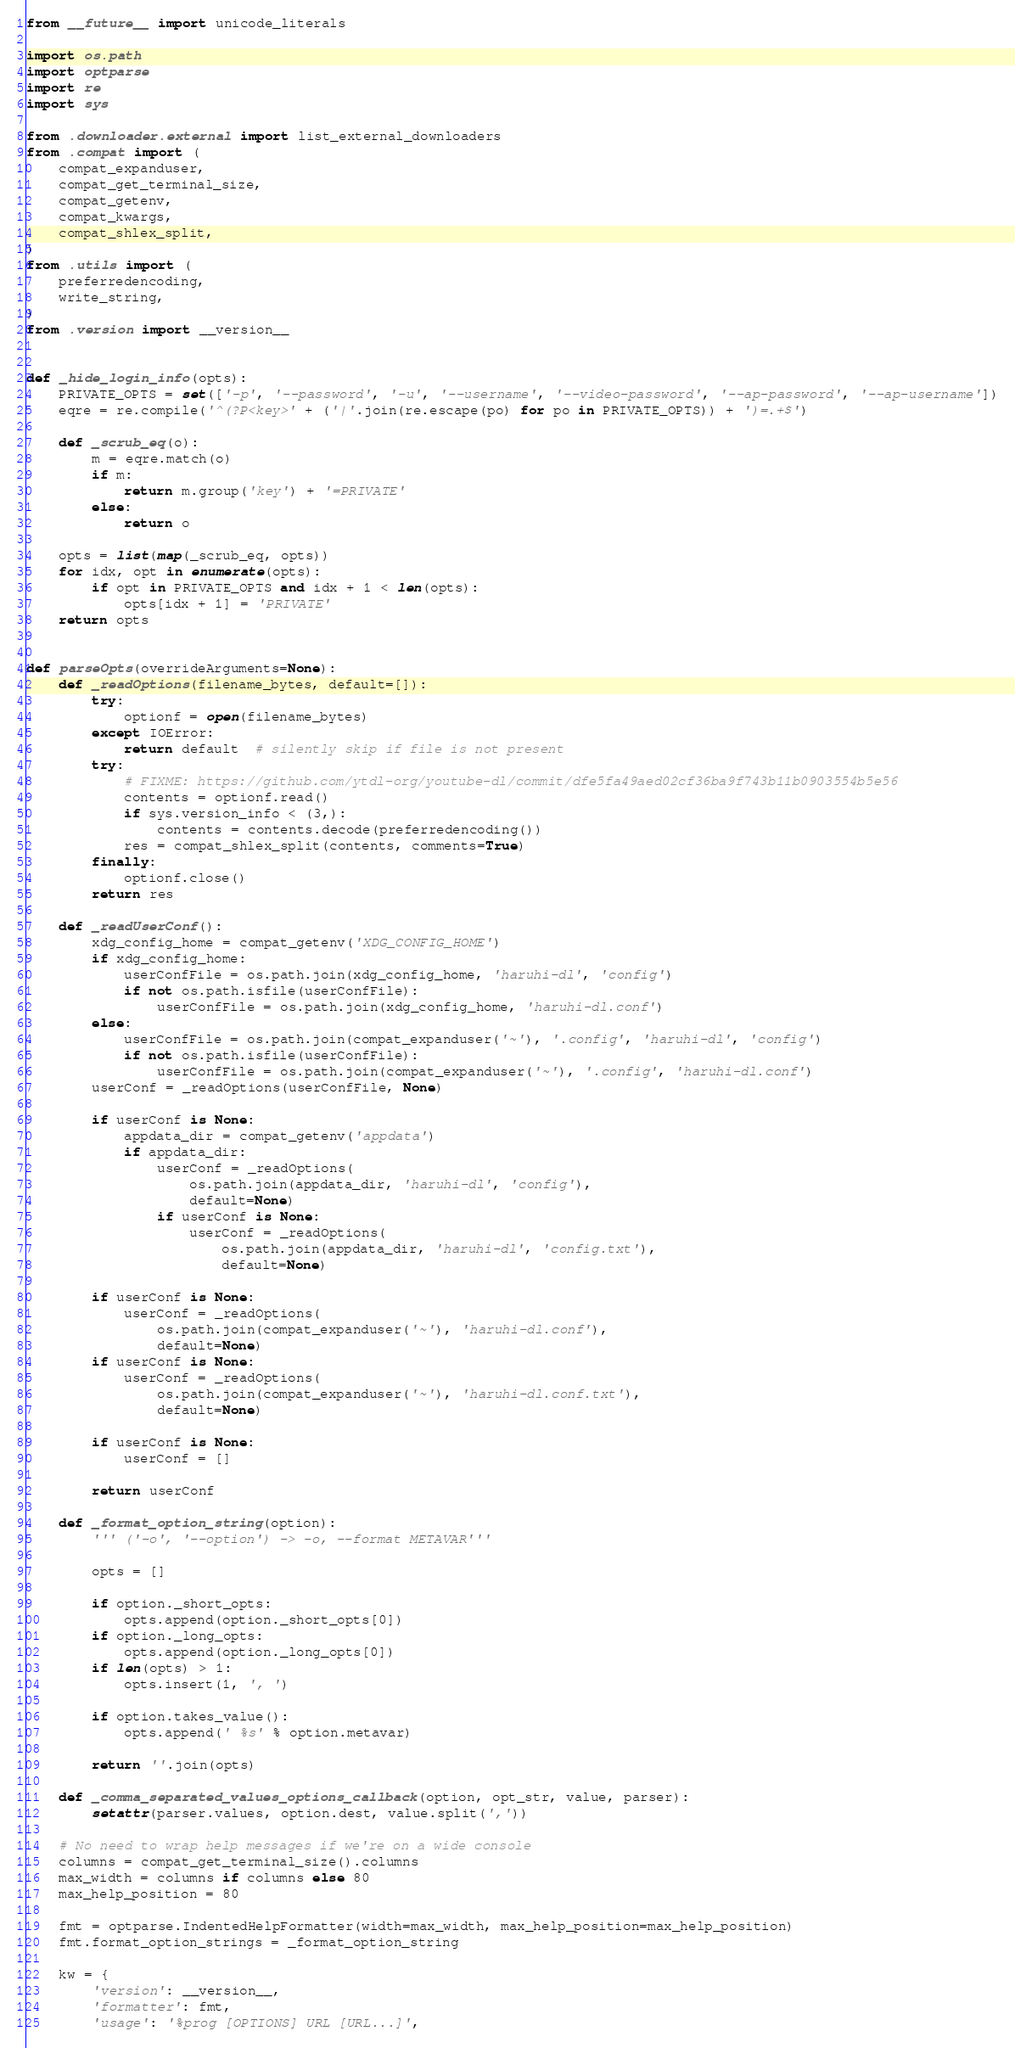<code> <loc_0><loc_0><loc_500><loc_500><_Python_>from __future__ import unicode_literals

import os.path
import optparse
import re
import sys

from .downloader.external import list_external_downloaders
from .compat import (
    compat_expanduser,
    compat_get_terminal_size,
    compat_getenv,
    compat_kwargs,
    compat_shlex_split,
)
from .utils import (
    preferredencoding,
    write_string,
)
from .version import __version__


def _hide_login_info(opts):
    PRIVATE_OPTS = set(['-p', '--password', '-u', '--username', '--video-password', '--ap-password', '--ap-username'])
    eqre = re.compile('^(?P<key>' + ('|'.join(re.escape(po) for po in PRIVATE_OPTS)) + ')=.+$')

    def _scrub_eq(o):
        m = eqre.match(o)
        if m:
            return m.group('key') + '=PRIVATE'
        else:
            return o

    opts = list(map(_scrub_eq, opts))
    for idx, opt in enumerate(opts):
        if opt in PRIVATE_OPTS and idx + 1 < len(opts):
            opts[idx + 1] = 'PRIVATE'
    return opts


def parseOpts(overrideArguments=None):
    def _readOptions(filename_bytes, default=[]):
        try:
            optionf = open(filename_bytes)
        except IOError:
            return default  # silently skip if file is not present
        try:
            # FIXME: https://github.com/ytdl-org/youtube-dl/commit/dfe5fa49aed02cf36ba9f743b11b0903554b5e56
            contents = optionf.read()
            if sys.version_info < (3,):
                contents = contents.decode(preferredencoding())
            res = compat_shlex_split(contents, comments=True)
        finally:
            optionf.close()
        return res

    def _readUserConf():
        xdg_config_home = compat_getenv('XDG_CONFIG_HOME')
        if xdg_config_home:
            userConfFile = os.path.join(xdg_config_home, 'haruhi-dl', 'config')
            if not os.path.isfile(userConfFile):
                userConfFile = os.path.join(xdg_config_home, 'haruhi-dl.conf')
        else:
            userConfFile = os.path.join(compat_expanduser('~'), '.config', 'haruhi-dl', 'config')
            if not os.path.isfile(userConfFile):
                userConfFile = os.path.join(compat_expanduser('~'), '.config', 'haruhi-dl.conf')
        userConf = _readOptions(userConfFile, None)

        if userConf is None:
            appdata_dir = compat_getenv('appdata')
            if appdata_dir:
                userConf = _readOptions(
                    os.path.join(appdata_dir, 'haruhi-dl', 'config'),
                    default=None)
                if userConf is None:
                    userConf = _readOptions(
                        os.path.join(appdata_dir, 'haruhi-dl', 'config.txt'),
                        default=None)

        if userConf is None:
            userConf = _readOptions(
                os.path.join(compat_expanduser('~'), 'haruhi-dl.conf'),
                default=None)
        if userConf is None:
            userConf = _readOptions(
                os.path.join(compat_expanduser('~'), 'haruhi-dl.conf.txt'),
                default=None)

        if userConf is None:
            userConf = []

        return userConf

    def _format_option_string(option):
        ''' ('-o', '--option') -> -o, --format METAVAR'''

        opts = []

        if option._short_opts:
            opts.append(option._short_opts[0])
        if option._long_opts:
            opts.append(option._long_opts[0])
        if len(opts) > 1:
            opts.insert(1, ', ')

        if option.takes_value():
            opts.append(' %s' % option.metavar)

        return ''.join(opts)

    def _comma_separated_values_options_callback(option, opt_str, value, parser):
        setattr(parser.values, option.dest, value.split(','))

    # No need to wrap help messages if we're on a wide console
    columns = compat_get_terminal_size().columns
    max_width = columns if columns else 80
    max_help_position = 80

    fmt = optparse.IndentedHelpFormatter(width=max_width, max_help_position=max_help_position)
    fmt.format_option_strings = _format_option_string

    kw = {
        'version': __version__,
        'formatter': fmt,
        'usage': '%prog [OPTIONS] URL [URL...]',</code> 